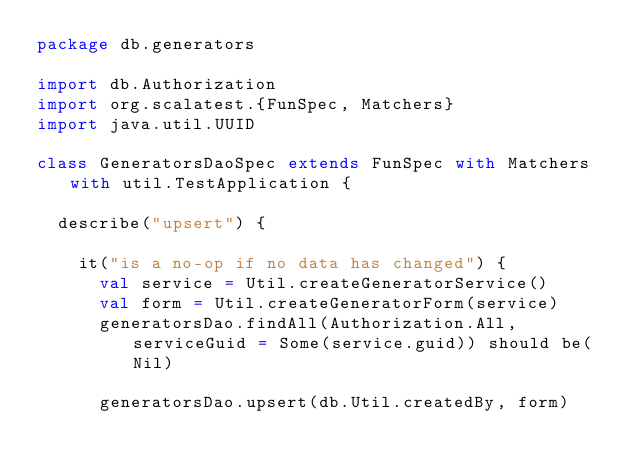<code> <loc_0><loc_0><loc_500><loc_500><_Scala_>package db.generators

import db.Authorization
import org.scalatest.{FunSpec, Matchers}
import java.util.UUID

class GeneratorsDaoSpec extends FunSpec with Matchers with util.TestApplication {

  describe("upsert") {

    it("is a no-op if no data has changed") {
      val service = Util.createGeneratorService()
      val form = Util.createGeneratorForm(service)
      generatorsDao.findAll(Authorization.All, serviceGuid = Some(service.guid)) should be(Nil)

      generatorsDao.upsert(db.Util.createdBy, form)</code> 